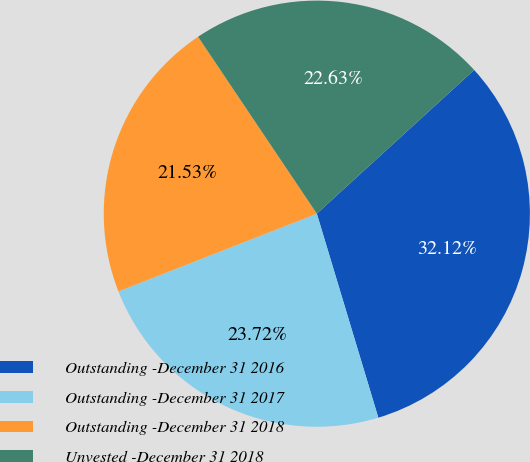Convert chart to OTSL. <chart><loc_0><loc_0><loc_500><loc_500><pie_chart><fcel>Outstanding -December 31 2016<fcel>Outstanding -December 31 2017<fcel>Outstanding -December 31 2018<fcel>Unvested -December 31 2018<nl><fcel>32.12%<fcel>23.72%<fcel>21.53%<fcel>22.63%<nl></chart> 